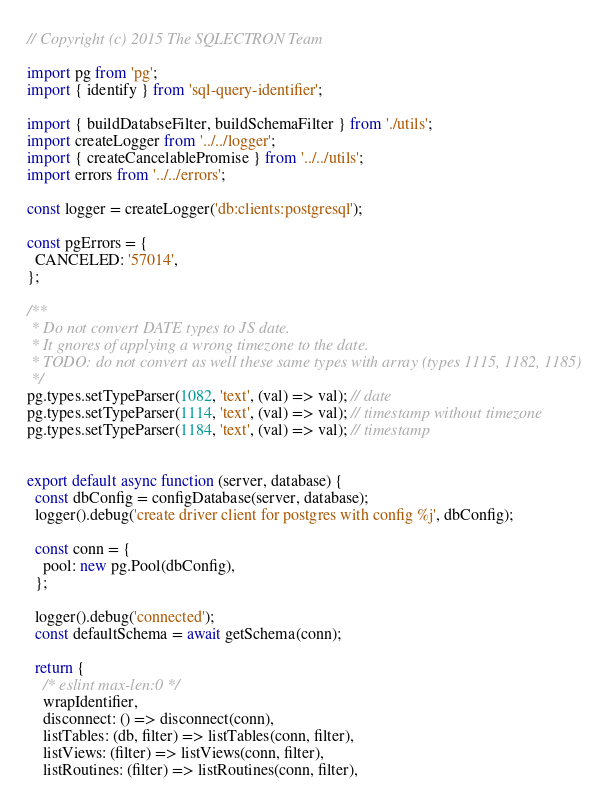<code> <loc_0><loc_0><loc_500><loc_500><_JavaScript_>// Copyright (c) 2015 The SQLECTRON Team

import pg from 'pg';
import { identify } from 'sql-query-identifier';

import { buildDatabseFilter, buildSchemaFilter } from './utils';
import createLogger from '../../logger';
import { createCancelablePromise } from '../../utils';
import errors from '../../errors';

const logger = createLogger('db:clients:postgresql');

const pgErrors = {
  CANCELED: '57014',
};

/**
 * Do not convert DATE types to JS date.
 * It gnores of applying a wrong timezone to the date.
 * TODO: do not convert as well these same types with array (types 1115, 1182, 1185)
 */
pg.types.setTypeParser(1082, 'text', (val) => val); // date
pg.types.setTypeParser(1114, 'text', (val) => val); // timestamp without timezone
pg.types.setTypeParser(1184, 'text', (val) => val); // timestamp


export default async function (server, database) {
  const dbConfig = configDatabase(server, database);
  logger().debug('create driver client for postgres with config %j', dbConfig);

  const conn = {
    pool: new pg.Pool(dbConfig),
  };

  logger().debug('connected');
  const defaultSchema = await getSchema(conn);

  return {
    /* eslint max-len:0 */
    wrapIdentifier,
    disconnect: () => disconnect(conn),
    listTables: (db, filter) => listTables(conn, filter),
    listViews: (filter) => listViews(conn, filter),
    listRoutines: (filter) => listRoutines(conn, filter),</code> 